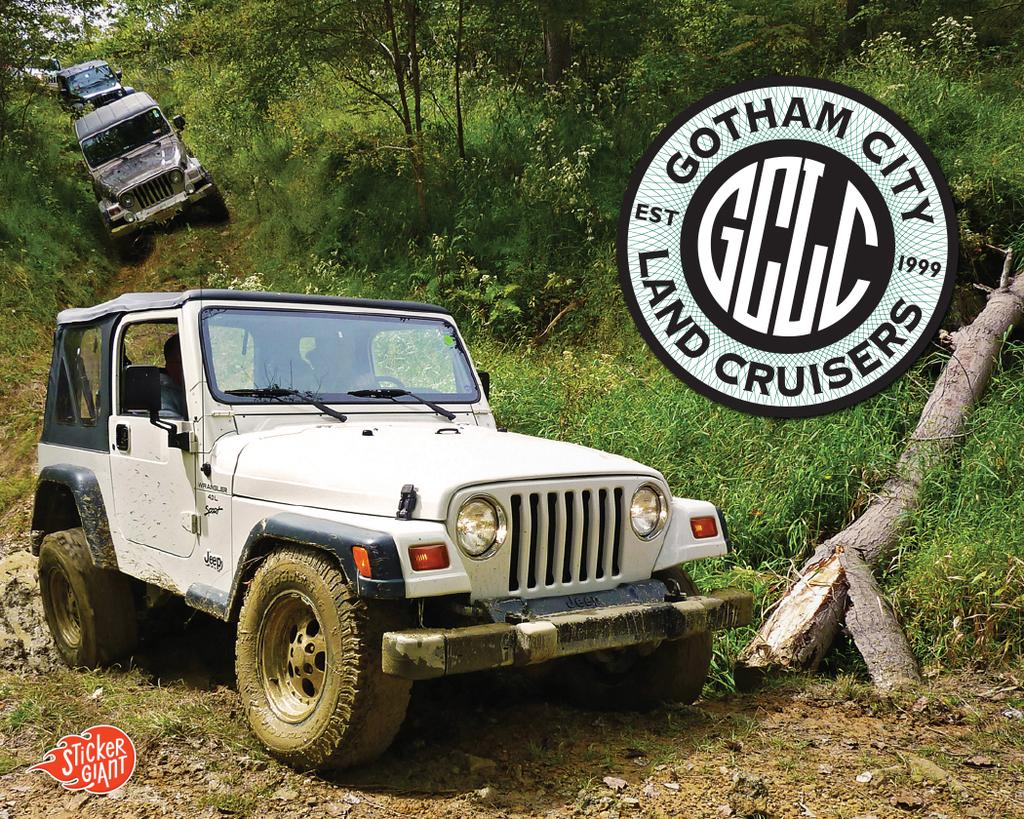What types of objects can be seen in the image? There are vehicles in the image. Can you describe the appearance of the vehicles? The vehicles are in different colors. What can be seen in the background of the image? There are trees visible in the background of the image. What type of vegetation is present in the image? Green grass is present in the image. What additional item can be found in the image? There is a stamp in the image. How does the wind affect the iron spade in the image? There is no wind, iron, or spade present in the image. 